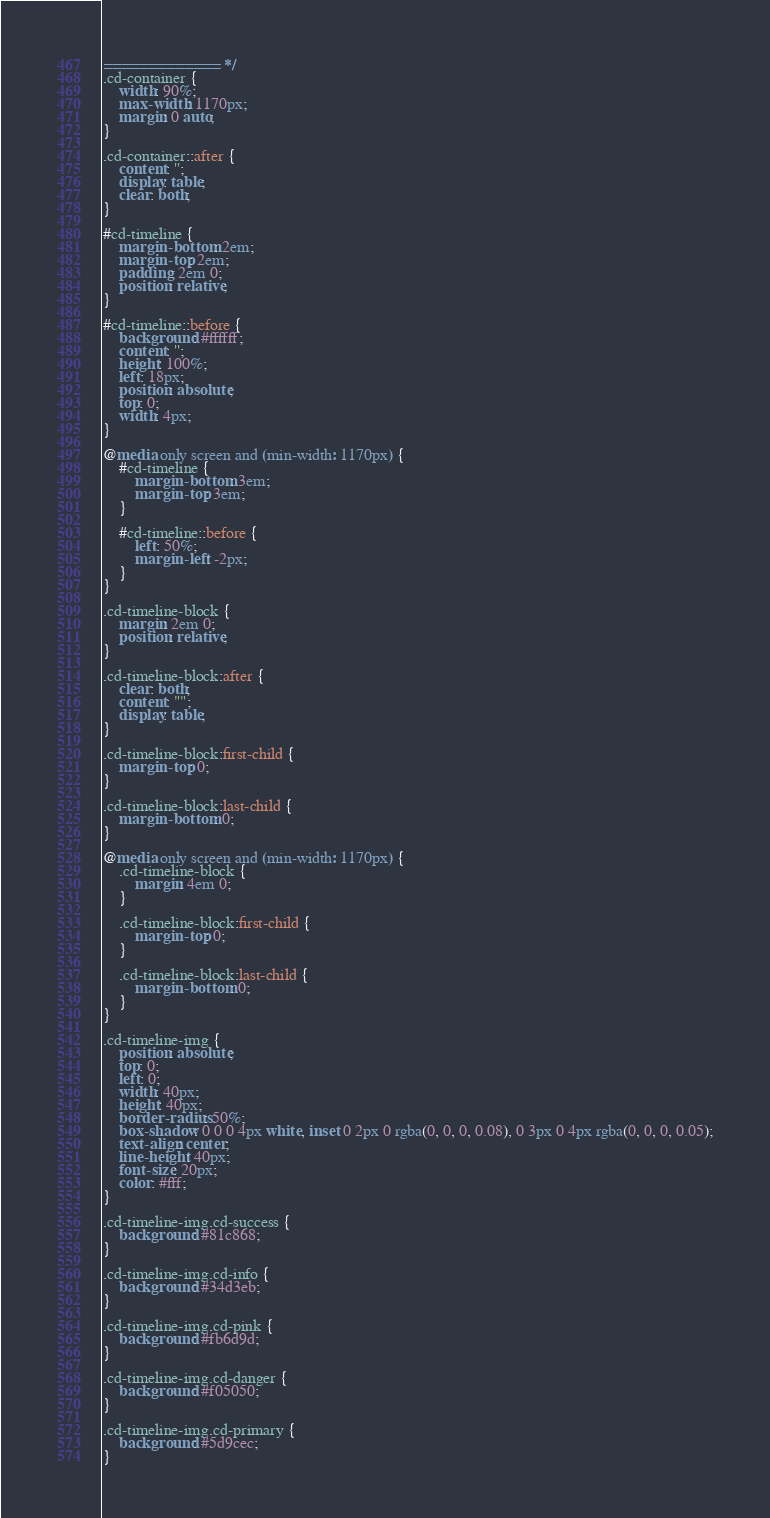<code> <loc_0><loc_0><loc_500><loc_500><_CSS_>============= */
.cd-container {
    width: 90%;
    max-width: 1170px;
    margin: 0 auto;
}

.cd-container::after {
    content: '';
    display: table;
    clear: both;
}

#cd-timeline {
    margin-bottom: 2em;
    margin-top: 2em;
    padding: 2em 0;
    position: relative;
}

#cd-timeline::before {
    background: #ffffff;
    content: '';
    height: 100%;
    left: 18px;
    position: absolute;
    top: 0;
    width: 4px;
}

@media only screen and (min-width: 1170px) {
    #cd-timeline {
        margin-bottom: 3em;
        margin-top: 3em;
    }

    #cd-timeline::before {
        left: 50%;
        margin-left: -2px;
    }
}

.cd-timeline-block {
    margin: 2em 0;
    position: relative;
}

.cd-timeline-block:after {
    clear: both;
    content: "";
    display: table;
}

.cd-timeline-block:first-child {
    margin-top: 0;
}

.cd-timeline-block:last-child {
    margin-bottom: 0;
}

@media only screen and (min-width: 1170px) {
    .cd-timeline-block {
        margin: 4em 0;
    }

    .cd-timeline-block:first-child {
        margin-top: 0;
    }

    .cd-timeline-block:last-child {
        margin-bottom: 0;
    }
}

.cd-timeline-img {
    position: absolute;
    top: 0;
    left: 0;
    width: 40px;
    height: 40px;
    border-radius: 50%;
    box-shadow: 0 0 0 4px white, inset 0 2px 0 rgba(0, 0, 0, 0.08), 0 3px 0 4px rgba(0, 0, 0, 0.05);
    text-align: center;
    line-height: 40px;
    font-size: 20px;
    color: #fff;
}

.cd-timeline-img.cd-success {
    background: #81c868;
}

.cd-timeline-img.cd-info {
    background: #34d3eb;
}

.cd-timeline-img.cd-pink {
    background: #fb6d9d;
}

.cd-timeline-img.cd-danger {
    background: #f05050;
}

.cd-timeline-img.cd-primary {
    background: #5d9cec;
}
</code> 